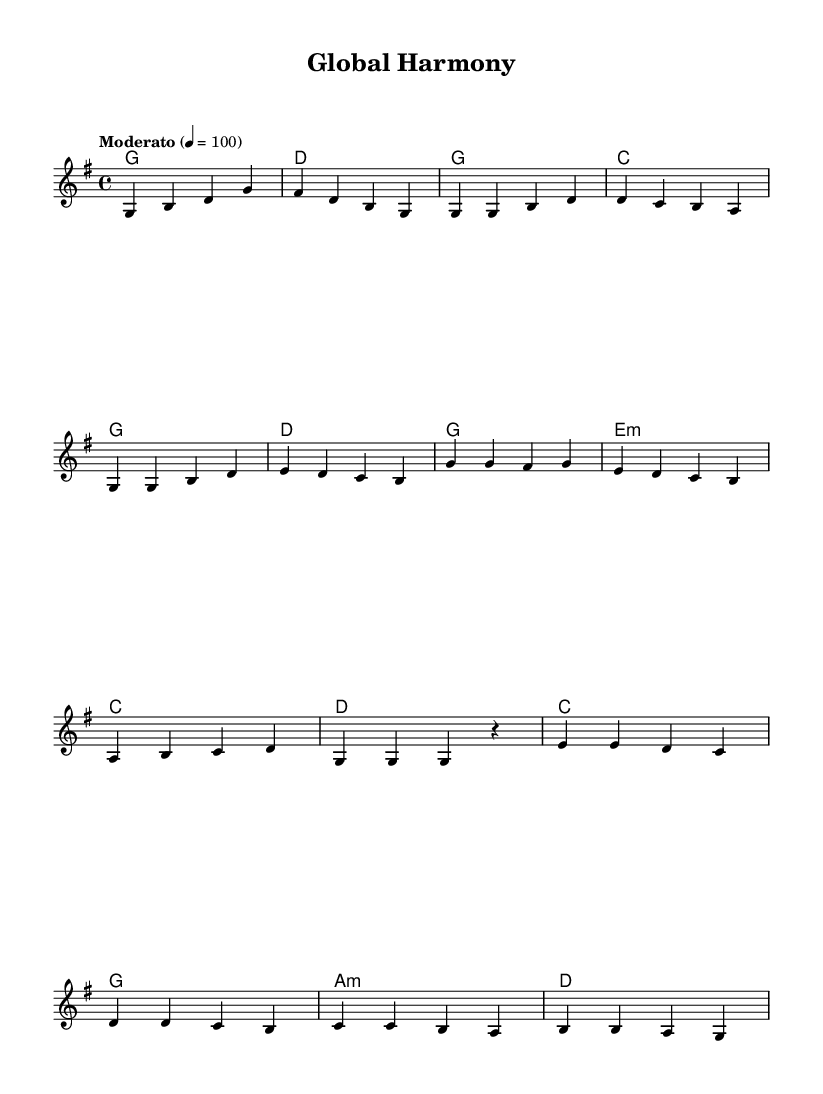What is the key signature of this music? The key signature is G major, which has one sharp (F#). It can be identified in the beginning of the staff where the sharp is placed on the F line.
Answer: G major What is the time signature of this piece? The time signature is 4/4, which indicates that there are four beats in each measure and the quarter note receives one beat. This is typically noted at the beginning of the staff.
Answer: 4/4 What is the tempo marking for this composition? The tempo marking is "Moderato", which suggests a moderate speed for the piece. Tempo markings are often indicated above the staff at the beginning.
Answer: Moderato How many measures are in the chorus section? The chorus section consists of four measures. By counting the measures from the notation labeled as the chorus, we find that it spans four distinct measures.
Answer: 4 Which chords are used during the bridge? The chords in the bridge are C, G, A minor, and D. These can be found in the chord mode section where the bridge's chords are listed.
Answer: C, G, A minor, D What type of musical style does this piece represent? This piece represents Folk Fusion, as it blends international styles, showcasing cultural exchange through its rhythmic and melodic structure. This is inferred from the general style mentioned in the title and the musical characteristics in the composition.
Answer: Folk Fusion 